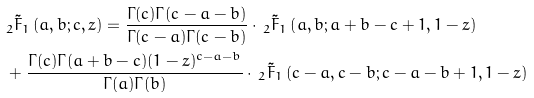Convert formula to latex. <formula><loc_0><loc_0><loc_500><loc_500>& _ { 2 } \tilde { F } _ { 1 } \left ( a , b ; c , z \right ) = \frac { \Gamma ( c ) \Gamma ( c - a - b ) } { \Gamma ( c - a ) \Gamma ( c - b ) } \cdot \, _ { 2 } \tilde { F } _ { 1 } \left ( a , b ; a + b - c + 1 , 1 - z \right ) \\ & + \frac { \Gamma ( c ) \Gamma ( a + b - c ) ( 1 - z ) ^ { c - a - b } } { \Gamma ( a ) \Gamma ( b ) } \cdot \, _ { 2 } \tilde { F } _ { 1 } \left ( c - a , c - b ; c - a - b + 1 , 1 - z \right )</formula> 